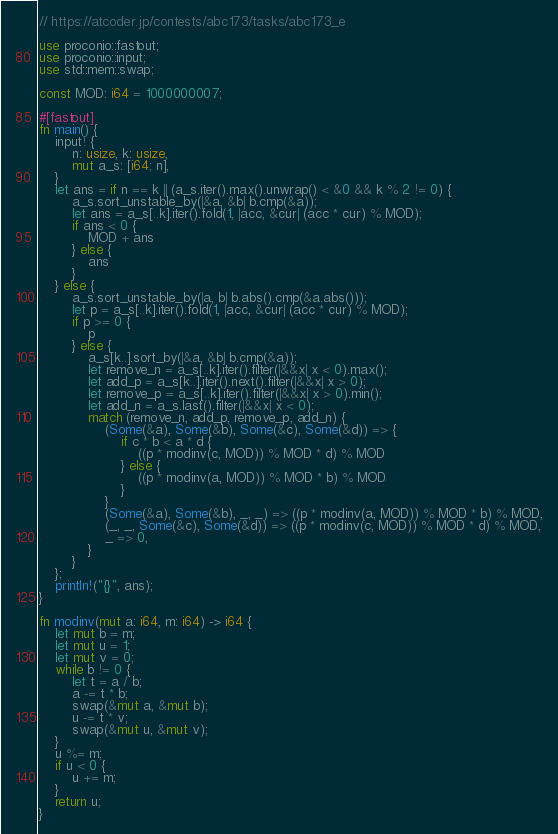<code> <loc_0><loc_0><loc_500><loc_500><_Rust_>// https://atcoder.jp/contests/abc173/tasks/abc173_e

use proconio::fastout;
use proconio::input;
use std::mem::swap;

const MOD: i64 = 1000000007;

#[fastout]
fn main() {
    input! {
        n: usize, k: usize,
        mut a_s: [i64; n],
    }
    let ans = if n == k || (a_s.iter().max().unwrap() < &0 && k % 2 != 0) {
        a_s.sort_unstable_by(|&a, &b| b.cmp(&a));
        let ans = a_s[..k].iter().fold(1, |acc, &cur| (acc * cur) % MOD);
        if ans < 0 {
            MOD + ans
        } else {
            ans
        }
    } else {
        a_s.sort_unstable_by(|a, b| b.abs().cmp(&a.abs()));
        let p = a_s[..k].iter().fold(1, |acc, &cur| (acc * cur) % MOD);
        if p >= 0 {
            p
        } else {
            a_s[k..].sort_by(|&a, &b| b.cmp(&a));
            let remove_n = a_s[..k].iter().filter(|&&x| x < 0).max();
            let add_p = a_s[k..].iter().next().filter(|&&x| x > 0);
            let remove_p = a_s[..k].iter().filter(|&&x| x > 0).min();
            let add_n = a_s.last().filter(|&&x| x < 0);
            match (remove_n, add_p, remove_p, add_n) {
                (Some(&a), Some(&b), Some(&c), Some(&d)) => {
                    if c * b < a * d {
                        ((p * modinv(c, MOD)) % MOD * d) % MOD
                    } else {
                        ((p * modinv(a, MOD)) % MOD * b) % MOD
                    }
                }
                (Some(&a), Some(&b), _, _) => ((p * modinv(a, MOD)) % MOD * b) % MOD,
                (_, _, Some(&c), Some(&d)) => ((p * modinv(c, MOD)) % MOD * d) % MOD,
                _ => 0,
            }
        }
    };
    println!("{}", ans);
}

fn modinv(mut a: i64, m: i64) -> i64 {
    let mut b = m;
    let mut u = 1;
    let mut v = 0;
    while b != 0 {
        let t = a / b;
        a -= t * b;
        swap(&mut a, &mut b);
        u -= t * v;
        swap(&mut u, &mut v);
    }
    u %= m;
    if u < 0 {
        u += m;
    }
    return u;
}
</code> 